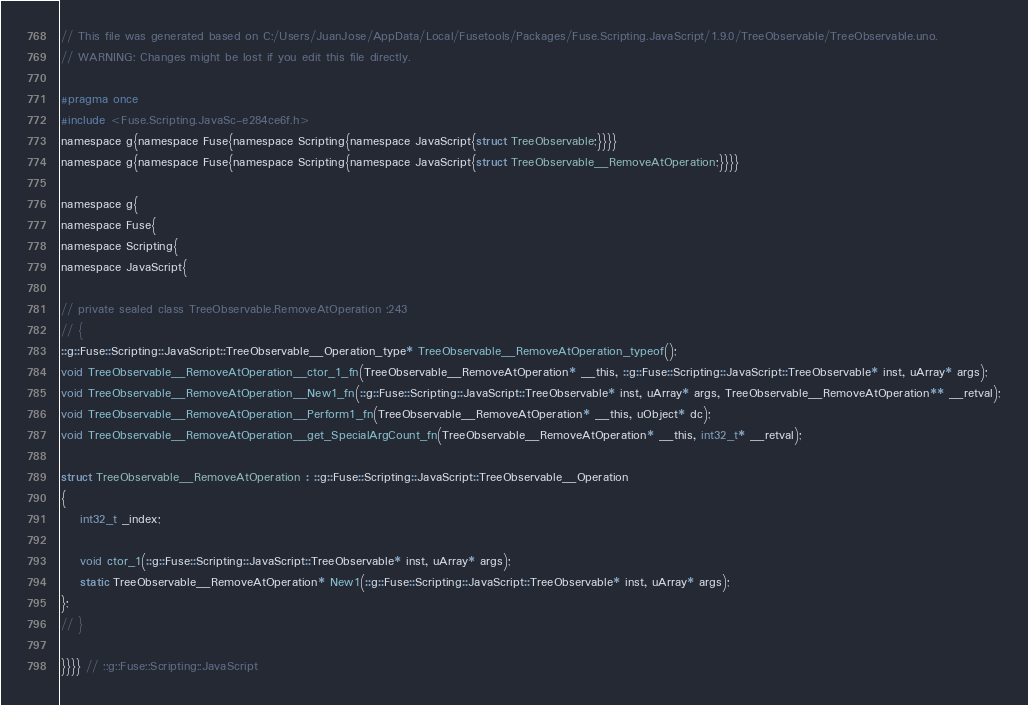<code> <loc_0><loc_0><loc_500><loc_500><_C_>// This file was generated based on C:/Users/JuanJose/AppData/Local/Fusetools/Packages/Fuse.Scripting.JavaScript/1.9.0/TreeObservable/TreeObservable.uno.
// WARNING: Changes might be lost if you edit this file directly.

#pragma once
#include <Fuse.Scripting.JavaSc-e284ce6f.h>
namespace g{namespace Fuse{namespace Scripting{namespace JavaScript{struct TreeObservable;}}}}
namespace g{namespace Fuse{namespace Scripting{namespace JavaScript{struct TreeObservable__RemoveAtOperation;}}}}

namespace g{
namespace Fuse{
namespace Scripting{
namespace JavaScript{

// private sealed class TreeObservable.RemoveAtOperation :243
// {
::g::Fuse::Scripting::JavaScript::TreeObservable__Operation_type* TreeObservable__RemoveAtOperation_typeof();
void TreeObservable__RemoveAtOperation__ctor_1_fn(TreeObservable__RemoveAtOperation* __this, ::g::Fuse::Scripting::JavaScript::TreeObservable* inst, uArray* args);
void TreeObservable__RemoveAtOperation__New1_fn(::g::Fuse::Scripting::JavaScript::TreeObservable* inst, uArray* args, TreeObservable__RemoveAtOperation** __retval);
void TreeObservable__RemoveAtOperation__Perform1_fn(TreeObservable__RemoveAtOperation* __this, uObject* dc);
void TreeObservable__RemoveAtOperation__get_SpecialArgCount_fn(TreeObservable__RemoveAtOperation* __this, int32_t* __retval);

struct TreeObservable__RemoveAtOperation : ::g::Fuse::Scripting::JavaScript::TreeObservable__Operation
{
    int32_t _index;

    void ctor_1(::g::Fuse::Scripting::JavaScript::TreeObservable* inst, uArray* args);
    static TreeObservable__RemoveAtOperation* New1(::g::Fuse::Scripting::JavaScript::TreeObservable* inst, uArray* args);
};
// }

}}}} // ::g::Fuse::Scripting::JavaScript
</code> 